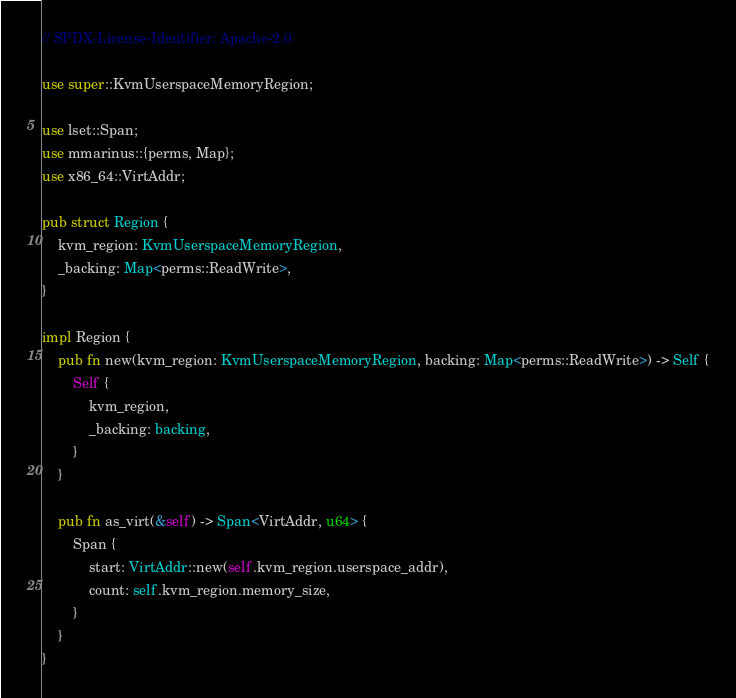Convert code to text. <code><loc_0><loc_0><loc_500><loc_500><_Rust_>// SPDX-License-Identifier: Apache-2.0

use super::KvmUserspaceMemoryRegion;

use lset::Span;
use mmarinus::{perms, Map};
use x86_64::VirtAddr;

pub struct Region {
    kvm_region: KvmUserspaceMemoryRegion,
    _backing: Map<perms::ReadWrite>,
}

impl Region {
    pub fn new(kvm_region: KvmUserspaceMemoryRegion, backing: Map<perms::ReadWrite>) -> Self {
        Self {
            kvm_region,
            _backing: backing,
        }
    }

    pub fn as_virt(&self) -> Span<VirtAddr, u64> {
        Span {
            start: VirtAddr::new(self.kvm_region.userspace_addr),
            count: self.kvm_region.memory_size,
        }
    }
}
</code> 